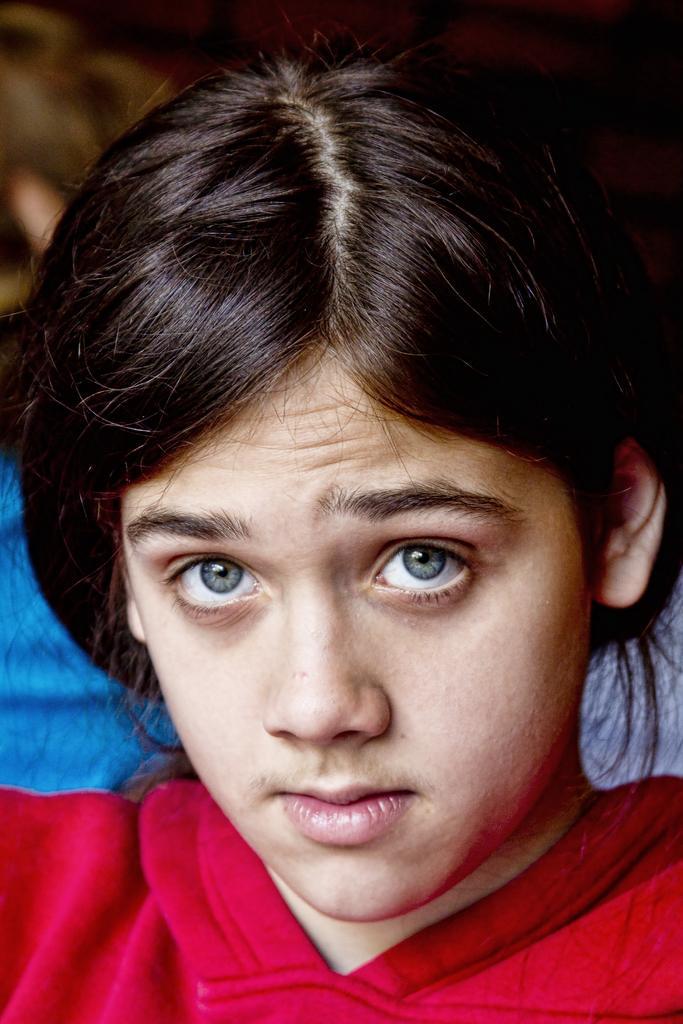Describe this image in one or two sentences. In this image we can see a person's face. 